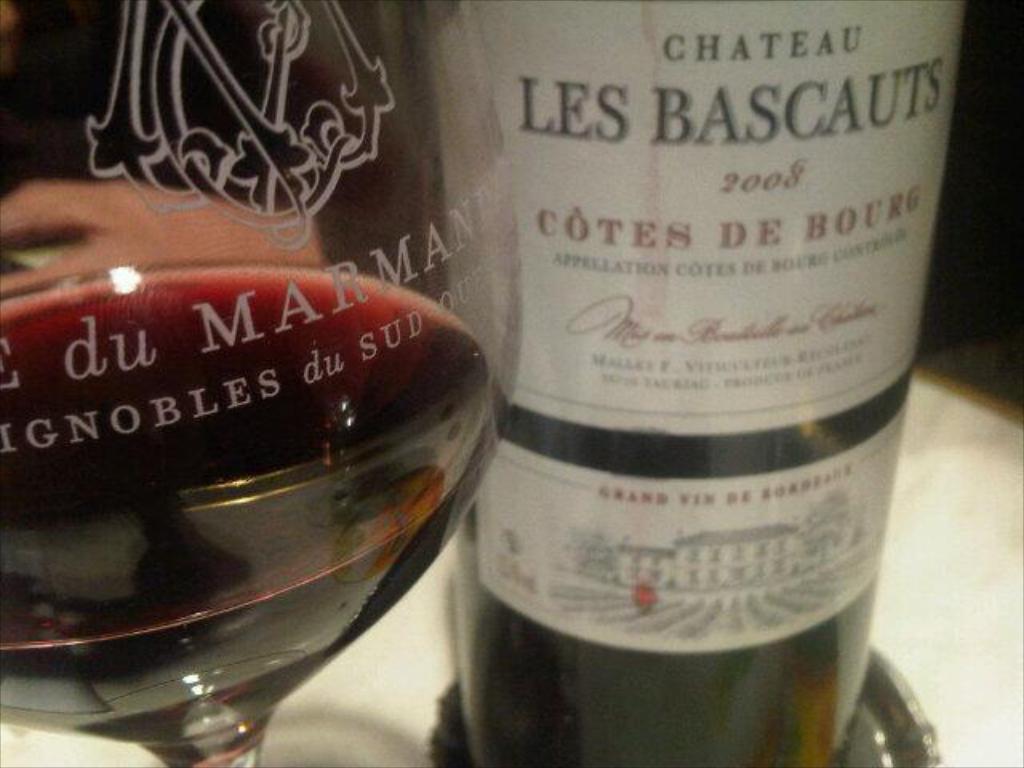Could you give a brief overview of what you see in this image? In this image in the center there is a glass and there is a bottle and there are some texts written on glass and bottle 